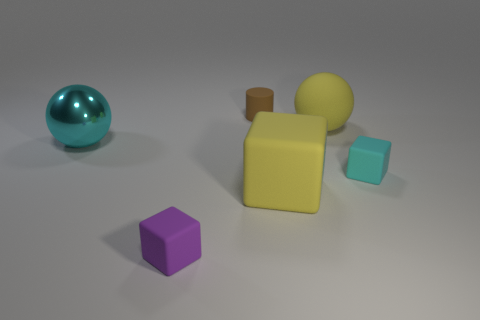Subtract all tiny blocks. How many blocks are left? 1 Add 1 yellow matte blocks. How many objects exist? 7 Subtract all spheres. How many objects are left? 4 Add 3 tiny purple matte blocks. How many tiny purple matte blocks are left? 4 Add 6 big cyan balls. How many big cyan balls exist? 7 Subtract 1 yellow cubes. How many objects are left? 5 Subtract all cyan metallic things. Subtract all balls. How many objects are left? 3 